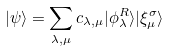<formula> <loc_0><loc_0><loc_500><loc_500>| \psi \rangle = \sum _ { \lambda , \mu } c _ { \lambda , \mu } | \phi _ { \lambda } ^ { R } \rangle | \xi _ { \mu } ^ { \sigma } \rangle</formula> 